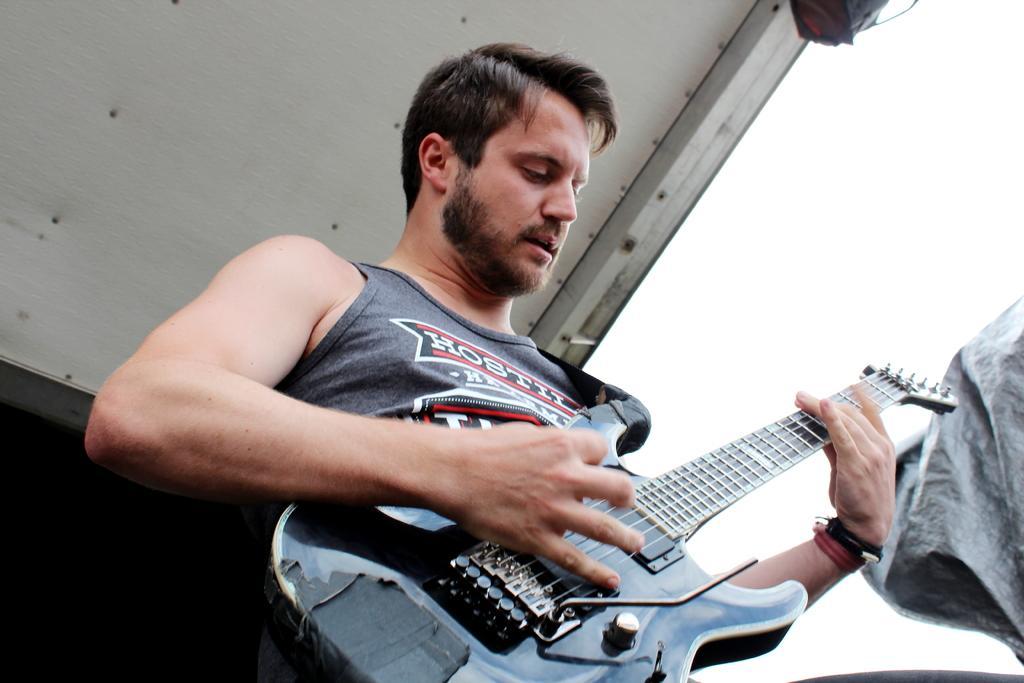How would you summarize this image in a sentence or two? In the picture only one person is present holding a guitar in his hands and wearing a grey shirt. 